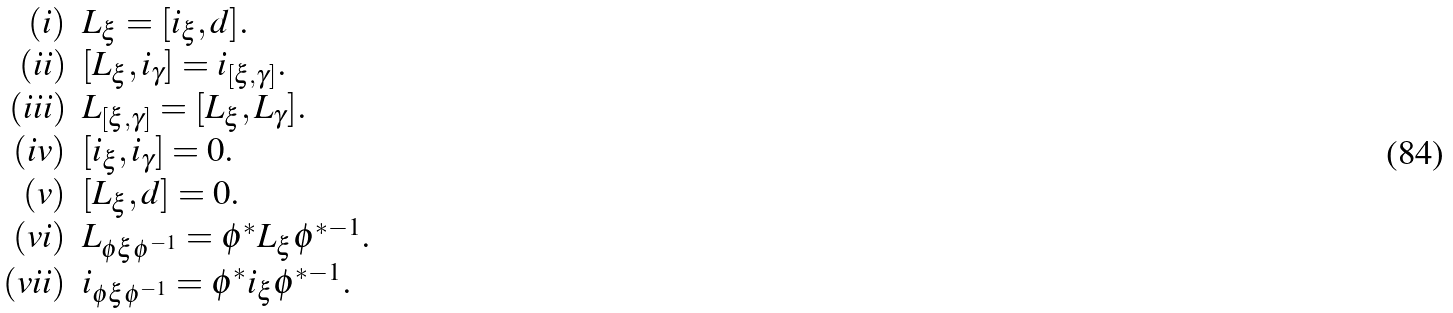Convert formula to latex. <formula><loc_0><loc_0><loc_500><loc_500>\begin{array} { r l } ( i ) & L _ { \xi } = [ i _ { \xi } , d ] . \\ ( i i ) & [ L _ { \xi } , i _ { \gamma } ] = i _ { [ \xi , \gamma ] } . \\ ( i i i ) & L _ { [ \xi , \gamma ] } = [ L _ { \xi } , L _ { \gamma } ] . \\ ( i v ) & [ i _ { \xi } , i _ { \gamma } ] = 0 . \\ ( v ) & [ L _ { \xi } , d ] = 0 . \\ ( v i ) & L _ { \phi \xi \phi ^ { - 1 } } = \phi ^ { * } L _ { \xi } \phi ^ { * - 1 } . \\ ( v i i ) & i _ { \phi \xi \phi ^ { - 1 } } = \phi ^ { * } i _ { \xi } \phi ^ { * - 1 } . \\ \end{array}</formula> 